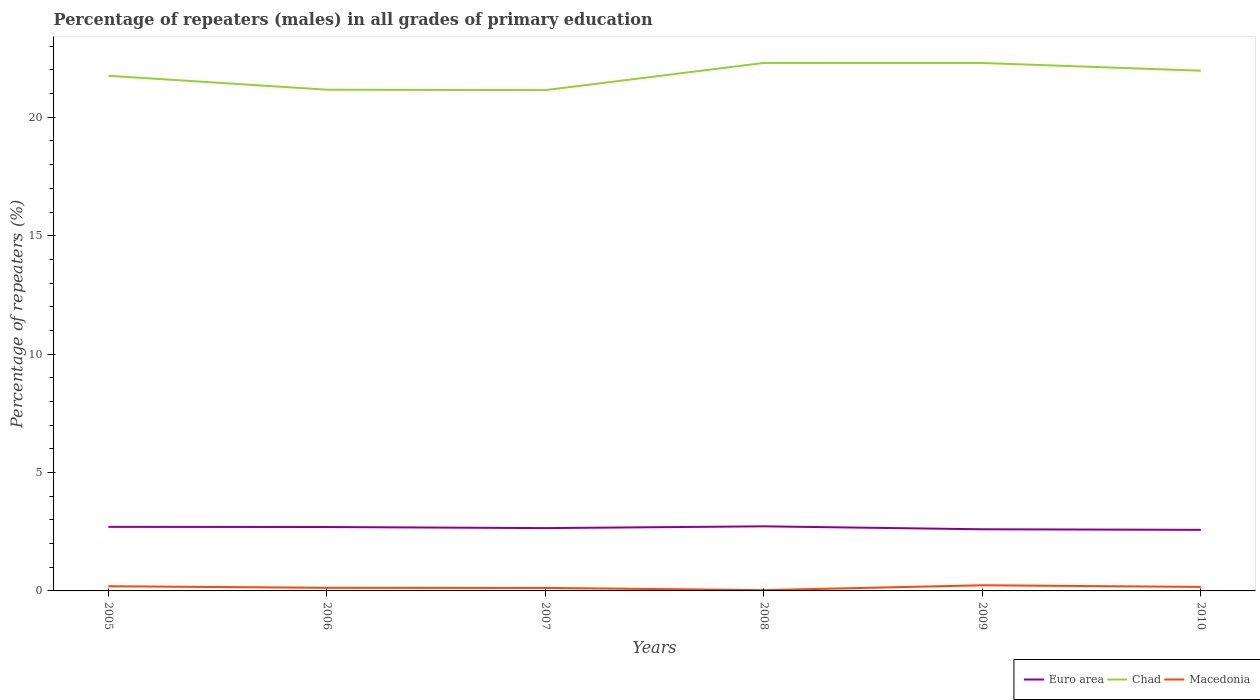How many different coloured lines are there?
Your answer should be compact. 3. Across all years, what is the maximum percentage of repeaters (males) in Macedonia?
Ensure brevity in your answer.  0.03. What is the total percentage of repeaters (males) in Macedonia in the graph?
Your response must be concise. 0.09. What is the difference between the highest and the second highest percentage of repeaters (males) in Macedonia?
Make the answer very short. 0.21. How many lines are there?
Your response must be concise. 3. Does the graph contain any zero values?
Offer a very short reply. No. Does the graph contain grids?
Offer a very short reply. No. Where does the legend appear in the graph?
Your response must be concise. Bottom right. How many legend labels are there?
Your answer should be very brief. 3. How are the legend labels stacked?
Your response must be concise. Horizontal. What is the title of the graph?
Your response must be concise. Percentage of repeaters (males) in all grades of primary education. Does "Mexico" appear as one of the legend labels in the graph?
Give a very brief answer. No. What is the label or title of the X-axis?
Make the answer very short. Years. What is the label or title of the Y-axis?
Provide a succinct answer. Percentage of repeaters (%). What is the Percentage of repeaters (%) of Euro area in 2005?
Offer a terse response. 2.71. What is the Percentage of repeaters (%) of Chad in 2005?
Keep it short and to the point. 21.75. What is the Percentage of repeaters (%) of Macedonia in 2005?
Provide a succinct answer. 0.2. What is the Percentage of repeaters (%) in Euro area in 2006?
Ensure brevity in your answer.  2.7. What is the Percentage of repeaters (%) of Chad in 2006?
Offer a very short reply. 21.16. What is the Percentage of repeaters (%) of Macedonia in 2006?
Provide a succinct answer. 0.13. What is the Percentage of repeaters (%) in Euro area in 2007?
Provide a succinct answer. 2.65. What is the Percentage of repeaters (%) in Chad in 2007?
Give a very brief answer. 21.15. What is the Percentage of repeaters (%) of Macedonia in 2007?
Your answer should be very brief. 0.13. What is the Percentage of repeaters (%) of Euro area in 2008?
Offer a very short reply. 2.73. What is the Percentage of repeaters (%) in Chad in 2008?
Your answer should be very brief. 22.29. What is the Percentage of repeaters (%) in Macedonia in 2008?
Your answer should be compact. 0.03. What is the Percentage of repeaters (%) in Euro area in 2009?
Provide a short and direct response. 2.6. What is the Percentage of repeaters (%) of Chad in 2009?
Ensure brevity in your answer.  22.29. What is the Percentage of repeaters (%) in Macedonia in 2009?
Offer a terse response. 0.24. What is the Percentage of repeaters (%) in Euro area in 2010?
Provide a succinct answer. 2.58. What is the Percentage of repeaters (%) of Chad in 2010?
Provide a short and direct response. 21.97. What is the Percentage of repeaters (%) of Macedonia in 2010?
Your answer should be very brief. 0.17. Across all years, what is the maximum Percentage of repeaters (%) in Euro area?
Provide a short and direct response. 2.73. Across all years, what is the maximum Percentage of repeaters (%) of Chad?
Make the answer very short. 22.29. Across all years, what is the maximum Percentage of repeaters (%) of Macedonia?
Offer a very short reply. 0.24. Across all years, what is the minimum Percentage of repeaters (%) of Euro area?
Offer a terse response. 2.58. Across all years, what is the minimum Percentage of repeaters (%) in Chad?
Your answer should be compact. 21.15. Across all years, what is the minimum Percentage of repeaters (%) in Macedonia?
Offer a very short reply. 0.03. What is the total Percentage of repeaters (%) in Euro area in the graph?
Offer a terse response. 15.97. What is the total Percentage of repeaters (%) of Chad in the graph?
Your answer should be compact. 130.62. What is the total Percentage of repeaters (%) of Macedonia in the graph?
Your response must be concise. 0.9. What is the difference between the Percentage of repeaters (%) in Euro area in 2005 and that in 2006?
Your answer should be very brief. 0.01. What is the difference between the Percentage of repeaters (%) in Chad in 2005 and that in 2006?
Offer a very short reply. 0.59. What is the difference between the Percentage of repeaters (%) of Macedonia in 2005 and that in 2006?
Your answer should be compact. 0.07. What is the difference between the Percentage of repeaters (%) of Euro area in 2005 and that in 2007?
Offer a terse response. 0.05. What is the difference between the Percentage of repeaters (%) in Chad in 2005 and that in 2007?
Provide a short and direct response. 0.61. What is the difference between the Percentage of repeaters (%) of Macedonia in 2005 and that in 2007?
Make the answer very short. 0.07. What is the difference between the Percentage of repeaters (%) of Euro area in 2005 and that in 2008?
Your answer should be very brief. -0.02. What is the difference between the Percentage of repeaters (%) of Chad in 2005 and that in 2008?
Keep it short and to the point. -0.54. What is the difference between the Percentage of repeaters (%) of Macedonia in 2005 and that in 2008?
Provide a short and direct response. 0.17. What is the difference between the Percentage of repeaters (%) of Euro area in 2005 and that in 2009?
Provide a succinct answer. 0.1. What is the difference between the Percentage of repeaters (%) of Chad in 2005 and that in 2009?
Offer a very short reply. -0.54. What is the difference between the Percentage of repeaters (%) of Macedonia in 2005 and that in 2009?
Ensure brevity in your answer.  -0.04. What is the difference between the Percentage of repeaters (%) in Euro area in 2005 and that in 2010?
Give a very brief answer. 0.13. What is the difference between the Percentage of repeaters (%) in Chad in 2005 and that in 2010?
Your answer should be compact. -0.21. What is the difference between the Percentage of repeaters (%) of Macedonia in 2005 and that in 2010?
Provide a succinct answer. 0.03. What is the difference between the Percentage of repeaters (%) of Euro area in 2006 and that in 2007?
Offer a very short reply. 0.05. What is the difference between the Percentage of repeaters (%) in Chad in 2006 and that in 2007?
Your response must be concise. 0.02. What is the difference between the Percentage of repeaters (%) in Macedonia in 2006 and that in 2007?
Offer a very short reply. 0. What is the difference between the Percentage of repeaters (%) of Euro area in 2006 and that in 2008?
Your answer should be very brief. -0.03. What is the difference between the Percentage of repeaters (%) of Chad in 2006 and that in 2008?
Make the answer very short. -1.13. What is the difference between the Percentage of repeaters (%) of Macedonia in 2006 and that in 2008?
Your response must be concise. 0.1. What is the difference between the Percentage of repeaters (%) in Euro area in 2006 and that in 2009?
Your answer should be compact. 0.1. What is the difference between the Percentage of repeaters (%) of Chad in 2006 and that in 2009?
Offer a very short reply. -1.13. What is the difference between the Percentage of repeaters (%) in Macedonia in 2006 and that in 2009?
Offer a very short reply. -0.11. What is the difference between the Percentage of repeaters (%) of Euro area in 2006 and that in 2010?
Your answer should be compact. 0.12. What is the difference between the Percentage of repeaters (%) in Chad in 2006 and that in 2010?
Keep it short and to the point. -0.8. What is the difference between the Percentage of repeaters (%) in Macedonia in 2006 and that in 2010?
Your response must be concise. -0.04. What is the difference between the Percentage of repeaters (%) in Euro area in 2007 and that in 2008?
Give a very brief answer. -0.07. What is the difference between the Percentage of repeaters (%) of Chad in 2007 and that in 2008?
Your answer should be compact. -1.15. What is the difference between the Percentage of repeaters (%) in Macedonia in 2007 and that in 2008?
Ensure brevity in your answer.  0.09. What is the difference between the Percentage of repeaters (%) in Euro area in 2007 and that in 2009?
Offer a terse response. 0.05. What is the difference between the Percentage of repeaters (%) in Chad in 2007 and that in 2009?
Provide a succinct answer. -1.15. What is the difference between the Percentage of repeaters (%) in Macedonia in 2007 and that in 2009?
Your response must be concise. -0.11. What is the difference between the Percentage of repeaters (%) in Euro area in 2007 and that in 2010?
Give a very brief answer. 0.07. What is the difference between the Percentage of repeaters (%) of Chad in 2007 and that in 2010?
Offer a terse response. -0.82. What is the difference between the Percentage of repeaters (%) in Macedonia in 2007 and that in 2010?
Make the answer very short. -0.04. What is the difference between the Percentage of repeaters (%) in Euro area in 2008 and that in 2009?
Offer a very short reply. 0.12. What is the difference between the Percentage of repeaters (%) in Chad in 2008 and that in 2009?
Your answer should be very brief. 0. What is the difference between the Percentage of repeaters (%) of Macedonia in 2008 and that in 2009?
Your answer should be very brief. -0.21. What is the difference between the Percentage of repeaters (%) of Euro area in 2008 and that in 2010?
Provide a succinct answer. 0.15. What is the difference between the Percentage of repeaters (%) in Chad in 2008 and that in 2010?
Your answer should be very brief. 0.33. What is the difference between the Percentage of repeaters (%) of Macedonia in 2008 and that in 2010?
Your answer should be very brief. -0.14. What is the difference between the Percentage of repeaters (%) in Euro area in 2009 and that in 2010?
Your answer should be very brief. 0.02. What is the difference between the Percentage of repeaters (%) of Chad in 2009 and that in 2010?
Your answer should be very brief. 0.33. What is the difference between the Percentage of repeaters (%) in Macedonia in 2009 and that in 2010?
Offer a terse response. 0.07. What is the difference between the Percentage of repeaters (%) in Euro area in 2005 and the Percentage of repeaters (%) in Chad in 2006?
Keep it short and to the point. -18.46. What is the difference between the Percentage of repeaters (%) in Euro area in 2005 and the Percentage of repeaters (%) in Macedonia in 2006?
Offer a very short reply. 2.58. What is the difference between the Percentage of repeaters (%) of Chad in 2005 and the Percentage of repeaters (%) of Macedonia in 2006?
Provide a succinct answer. 21.62. What is the difference between the Percentage of repeaters (%) in Euro area in 2005 and the Percentage of repeaters (%) in Chad in 2007?
Your answer should be compact. -18.44. What is the difference between the Percentage of repeaters (%) in Euro area in 2005 and the Percentage of repeaters (%) in Macedonia in 2007?
Provide a short and direct response. 2.58. What is the difference between the Percentage of repeaters (%) in Chad in 2005 and the Percentage of repeaters (%) in Macedonia in 2007?
Your answer should be very brief. 21.63. What is the difference between the Percentage of repeaters (%) in Euro area in 2005 and the Percentage of repeaters (%) in Chad in 2008?
Keep it short and to the point. -19.59. What is the difference between the Percentage of repeaters (%) in Euro area in 2005 and the Percentage of repeaters (%) in Macedonia in 2008?
Your answer should be very brief. 2.67. What is the difference between the Percentage of repeaters (%) of Chad in 2005 and the Percentage of repeaters (%) of Macedonia in 2008?
Keep it short and to the point. 21.72. What is the difference between the Percentage of repeaters (%) in Euro area in 2005 and the Percentage of repeaters (%) in Chad in 2009?
Offer a terse response. -19.59. What is the difference between the Percentage of repeaters (%) of Euro area in 2005 and the Percentage of repeaters (%) of Macedonia in 2009?
Give a very brief answer. 2.47. What is the difference between the Percentage of repeaters (%) in Chad in 2005 and the Percentage of repeaters (%) in Macedonia in 2009?
Ensure brevity in your answer.  21.51. What is the difference between the Percentage of repeaters (%) of Euro area in 2005 and the Percentage of repeaters (%) of Chad in 2010?
Make the answer very short. -19.26. What is the difference between the Percentage of repeaters (%) in Euro area in 2005 and the Percentage of repeaters (%) in Macedonia in 2010?
Offer a very short reply. 2.54. What is the difference between the Percentage of repeaters (%) of Chad in 2005 and the Percentage of repeaters (%) of Macedonia in 2010?
Your answer should be compact. 21.58. What is the difference between the Percentage of repeaters (%) in Euro area in 2006 and the Percentage of repeaters (%) in Chad in 2007?
Offer a very short reply. -18.45. What is the difference between the Percentage of repeaters (%) of Euro area in 2006 and the Percentage of repeaters (%) of Macedonia in 2007?
Provide a short and direct response. 2.57. What is the difference between the Percentage of repeaters (%) of Chad in 2006 and the Percentage of repeaters (%) of Macedonia in 2007?
Offer a terse response. 21.04. What is the difference between the Percentage of repeaters (%) in Euro area in 2006 and the Percentage of repeaters (%) in Chad in 2008?
Provide a short and direct response. -19.6. What is the difference between the Percentage of repeaters (%) of Euro area in 2006 and the Percentage of repeaters (%) of Macedonia in 2008?
Give a very brief answer. 2.67. What is the difference between the Percentage of repeaters (%) in Chad in 2006 and the Percentage of repeaters (%) in Macedonia in 2008?
Provide a succinct answer. 21.13. What is the difference between the Percentage of repeaters (%) of Euro area in 2006 and the Percentage of repeaters (%) of Chad in 2009?
Provide a succinct answer. -19.59. What is the difference between the Percentage of repeaters (%) in Euro area in 2006 and the Percentage of repeaters (%) in Macedonia in 2009?
Keep it short and to the point. 2.46. What is the difference between the Percentage of repeaters (%) of Chad in 2006 and the Percentage of repeaters (%) of Macedonia in 2009?
Give a very brief answer. 20.93. What is the difference between the Percentage of repeaters (%) of Euro area in 2006 and the Percentage of repeaters (%) of Chad in 2010?
Your answer should be very brief. -19.27. What is the difference between the Percentage of repeaters (%) in Euro area in 2006 and the Percentage of repeaters (%) in Macedonia in 2010?
Ensure brevity in your answer.  2.53. What is the difference between the Percentage of repeaters (%) of Chad in 2006 and the Percentage of repeaters (%) of Macedonia in 2010?
Provide a short and direct response. 20.99. What is the difference between the Percentage of repeaters (%) in Euro area in 2007 and the Percentage of repeaters (%) in Chad in 2008?
Your answer should be very brief. -19.64. What is the difference between the Percentage of repeaters (%) in Euro area in 2007 and the Percentage of repeaters (%) in Macedonia in 2008?
Provide a short and direct response. 2.62. What is the difference between the Percentage of repeaters (%) in Chad in 2007 and the Percentage of repeaters (%) in Macedonia in 2008?
Ensure brevity in your answer.  21.12. What is the difference between the Percentage of repeaters (%) in Euro area in 2007 and the Percentage of repeaters (%) in Chad in 2009?
Provide a succinct answer. -19.64. What is the difference between the Percentage of repeaters (%) of Euro area in 2007 and the Percentage of repeaters (%) of Macedonia in 2009?
Make the answer very short. 2.41. What is the difference between the Percentage of repeaters (%) in Chad in 2007 and the Percentage of repeaters (%) in Macedonia in 2009?
Make the answer very short. 20.91. What is the difference between the Percentage of repeaters (%) in Euro area in 2007 and the Percentage of repeaters (%) in Chad in 2010?
Give a very brief answer. -19.31. What is the difference between the Percentage of repeaters (%) in Euro area in 2007 and the Percentage of repeaters (%) in Macedonia in 2010?
Your response must be concise. 2.48. What is the difference between the Percentage of repeaters (%) of Chad in 2007 and the Percentage of repeaters (%) of Macedonia in 2010?
Provide a short and direct response. 20.98. What is the difference between the Percentage of repeaters (%) of Euro area in 2008 and the Percentage of repeaters (%) of Chad in 2009?
Your response must be concise. -19.56. What is the difference between the Percentage of repeaters (%) in Euro area in 2008 and the Percentage of repeaters (%) in Macedonia in 2009?
Give a very brief answer. 2.49. What is the difference between the Percentage of repeaters (%) in Chad in 2008 and the Percentage of repeaters (%) in Macedonia in 2009?
Your answer should be very brief. 22.06. What is the difference between the Percentage of repeaters (%) in Euro area in 2008 and the Percentage of repeaters (%) in Chad in 2010?
Offer a terse response. -19.24. What is the difference between the Percentage of repeaters (%) in Euro area in 2008 and the Percentage of repeaters (%) in Macedonia in 2010?
Offer a very short reply. 2.56. What is the difference between the Percentage of repeaters (%) in Chad in 2008 and the Percentage of repeaters (%) in Macedonia in 2010?
Keep it short and to the point. 22.12. What is the difference between the Percentage of repeaters (%) of Euro area in 2009 and the Percentage of repeaters (%) of Chad in 2010?
Offer a very short reply. -19.36. What is the difference between the Percentage of repeaters (%) in Euro area in 2009 and the Percentage of repeaters (%) in Macedonia in 2010?
Your response must be concise. 2.43. What is the difference between the Percentage of repeaters (%) of Chad in 2009 and the Percentage of repeaters (%) of Macedonia in 2010?
Keep it short and to the point. 22.12. What is the average Percentage of repeaters (%) of Euro area per year?
Ensure brevity in your answer.  2.66. What is the average Percentage of repeaters (%) of Chad per year?
Ensure brevity in your answer.  21.77. What is the average Percentage of repeaters (%) in Macedonia per year?
Your response must be concise. 0.15. In the year 2005, what is the difference between the Percentage of repeaters (%) of Euro area and Percentage of repeaters (%) of Chad?
Your answer should be compact. -19.05. In the year 2005, what is the difference between the Percentage of repeaters (%) in Euro area and Percentage of repeaters (%) in Macedonia?
Give a very brief answer. 2.51. In the year 2005, what is the difference between the Percentage of repeaters (%) of Chad and Percentage of repeaters (%) of Macedonia?
Ensure brevity in your answer.  21.55. In the year 2006, what is the difference between the Percentage of repeaters (%) of Euro area and Percentage of repeaters (%) of Chad?
Ensure brevity in your answer.  -18.47. In the year 2006, what is the difference between the Percentage of repeaters (%) of Euro area and Percentage of repeaters (%) of Macedonia?
Offer a very short reply. 2.57. In the year 2006, what is the difference between the Percentage of repeaters (%) in Chad and Percentage of repeaters (%) in Macedonia?
Provide a short and direct response. 21.03. In the year 2007, what is the difference between the Percentage of repeaters (%) in Euro area and Percentage of repeaters (%) in Chad?
Ensure brevity in your answer.  -18.49. In the year 2007, what is the difference between the Percentage of repeaters (%) in Euro area and Percentage of repeaters (%) in Macedonia?
Provide a succinct answer. 2.53. In the year 2007, what is the difference between the Percentage of repeaters (%) of Chad and Percentage of repeaters (%) of Macedonia?
Offer a terse response. 21.02. In the year 2008, what is the difference between the Percentage of repeaters (%) of Euro area and Percentage of repeaters (%) of Chad?
Offer a terse response. -19.57. In the year 2008, what is the difference between the Percentage of repeaters (%) of Euro area and Percentage of repeaters (%) of Macedonia?
Give a very brief answer. 2.7. In the year 2008, what is the difference between the Percentage of repeaters (%) in Chad and Percentage of repeaters (%) in Macedonia?
Provide a succinct answer. 22.26. In the year 2009, what is the difference between the Percentage of repeaters (%) in Euro area and Percentage of repeaters (%) in Chad?
Offer a very short reply. -19.69. In the year 2009, what is the difference between the Percentage of repeaters (%) of Euro area and Percentage of repeaters (%) of Macedonia?
Offer a terse response. 2.36. In the year 2009, what is the difference between the Percentage of repeaters (%) of Chad and Percentage of repeaters (%) of Macedonia?
Provide a succinct answer. 22.05. In the year 2010, what is the difference between the Percentage of repeaters (%) of Euro area and Percentage of repeaters (%) of Chad?
Give a very brief answer. -19.39. In the year 2010, what is the difference between the Percentage of repeaters (%) in Euro area and Percentage of repeaters (%) in Macedonia?
Provide a short and direct response. 2.41. In the year 2010, what is the difference between the Percentage of repeaters (%) in Chad and Percentage of repeaters (%) in Macedonia?
Offer a terse response. 21.8. What is the ratio of the Percentage of repeaters (%) in Euro area in 2005 to that in 2006?
Offer a very short reply. 1. What is the ratio of the Percentage of repeaters (%) of Chad in 2005 to that in 2006?
Keep it short and to the point. 1.03. What is the ratio of the Percentage of repeaters (%) in Macedonia in 2005 to that in 2006?
Offer a terse response. 1.52. What is the ratio of the Percentage of repeaters (%) of Euro area in 2005 to that in 2007?
Make the answer very short. 1.02. What is the ratio of the Percentage of repeaters (%) in Chad in 2005 to that in 2007?
Your answer should be compact. 1.03. What is the ratio of the Percentage of repeaters (%) of Macedonia in 2005 to that in 2007?
Offer a very short reply. 1.57. What is the ratio of the Percentage of repeaters (%) in Euro area in 2005 to that in 2008?
Ensure brevity in your answer.  0.99. What is the ratio of the Percentage of repeaters (%) in Chad in 2005 to that in 2008?
Your answer should be very brief. 0.98. What is the ratio of the Percentage of repeaters (%) in Macedonia in 2005 to that in 2008?
Keep it short and to the point. 6.2. What is the ratio of the Percentage of repeaters (%) in Euro area in 2005 to that in 2009?
Ensure brevity in your answer.  1.04. What is the ratio of the Percentage of repeaters (%) in Chad in 2005 to that in 2009?
Keep it short and to the point. 0.98. What is the ratio of the Percentage of repeaters (%) in Macedonia in 2005 to that in 2009?
Your response must be concise. 0.83. What is the ratio of the Percentage of repeaters (%) in Euro area in 2005 to that in 2010?
Offer a very short reply. 1.05. What is the ratio of the Percentage of repeaters (%) in Chad in 2005 to that in 2010?
Ensure brevity in your answer.  0.99. What is the ratio of the Percentage of repeaters (%) in Macedonia in 2005 to that in 2010?
Give a very brief answer. 1.17. What is the ratio of the Percentage of repeaters (%) in Euro area in 2006 to that in 2007?
Make the answer very short. 1.02. What is the ratio of the Percentage of repeaters (%) of Macedonia in 2006 to that in 2007?
Provide a succinct answer. 1.03. What is the ratio of the Percentage of repeaters (%) in Euro area in 2006 to that in 2008?
Provide a succinct answer. 0.99. What is the ratio of the Percentage of repeaters (%) of Chad in 2006 to that in 2008?
Offer a terse response. 0.95. What is the ratio of the Percentage of repeaters (%) of Macedonia in 2006 to that in 2008?
Your answer should be very brief. 4.07. What is the ratio of the Percentage of repeaters (%) in Euro area in 2006 to that in 2009?
Your answer should be compact. 1.04. What is the ratio of the Percentage of repeaters (%) in Chad in 2006 to that in 2009?
Give a very brief answer. 0.95. What is the ratio of the Percentage of repeaters (%) of Macedonia in 2006 to that in 2009?
Give a very brief answer. 0.55. What is the ratio of the Percentage of repeaters (%) in Euro area in 2006 to that in 2010?
Make the answer very short. 1.05. What is the ratio of the Percentage of repeaters (%) of Chad in 2006 to that in 2010?
Provide a short and direct response. 0.96. What is the ratio of the Percentage of repeaters (%) of Macedonia in 2006 to that in 2010?
Provide a short and direct response. 0.77. What is the ratio of the Percentage of repeaters (%) of Euro area in 2007 to that in 2008?
Keep it short and to the point. 0.97. What is the ratio of the Percentage of repeaters (%) in Chad in 2007 to that in 2008?
Offer a very short reply. 0.95. What is the ratio of the Percentage of repeaters (%) of Macedonia in 2007 to that in 2008?
Offer a very short reply. 3.95. What is the ratio of the Percentage of repeaters (%) of Euro area in 2007 to that in 2009?
Offer a very short reply. 1.02. What is the ratio of the Percentage of repeaters (%) in Chad in 2007 to that in 2009?
Give a very brief answer. 0.95. What is the ratio of the Percentage of repeaters (%) in Macedonia in 2007 to that in 2009?
Offer a very short reply. 0.53. What is the ratio of the Percentage of repeaters (%) in Euro area in 2007 to that in 2010?
Your answer should be compact. 1.03. What is the ratio of the Percentage of repeaters (%) of Chad in 2007 to that in 2010?
Give a very brief answer. 0.96. What is the ratio of the Percentage of repeaters (%) of Macedonia in 2007 to that in 2010?
Keep it short and to the point. 0.74. What is the ratio of the Percentage of repeaters (%) in Euro area in 2008 to that in 2009?
Keep it short and to the point. 1.05. What is the ratio of the Percentage of repeaters (%) in Macedonia in 2008 to that in 2009?
Keep it short and to the point. 0.13. What is the ratio of the Percentage of repeaters (%) of Euro area in 2008 to that in 2010?
Provide a short and direct response. 1.06. What is the ratio of the Percentage of repeaters (%) of Chad in 2008 to that in 2010?
Ensure brevity in your answer.  1.01. What is the ratio of the Percentage of repeaters (%) in Macedonia in 2008 to that in 2010?
Your response must be concise. 0.19. What is the ratio of the Percentage of repeaters (%) in Euro area in 2009 to that in 2010?
Your answer should be compact. 1.01. What is the ratio of the Percentage of repeaters (%) of Chad in 2009 to that in 2010?
Your response must be concise. 1.01. What is the ratio of the Percentage of repeaters (%) of Macedonia in 2009 to that in 2010?
Keep it short and to the point. 1.41. What is the difference between the highest and the second highest Percentage of repeaters (%) of Euro area?
Your response must be concise. 0.02. What is the difference between the highest and the second highest Percentage of repeaters (%) of Chad?
Your answer should be compact. 0. What is the difference between the highest and the second highest Percentage of repeaters (%) in Macedonia?
Your answer should be compact. 0.04. What is the difference between the highest and the lowest Percentage of repeaters (%) of Euro area?
Your response must be concise. 0.15. What is the difference between the highest and the lowest Percentage of repeaters (%) of Chad?
Keep it short and to the point. 1.15. What is the difference between the highest and the lowest Percentage of repeaters (%) in Macedonia?
Ensure brevity in your answer.  0.21. 